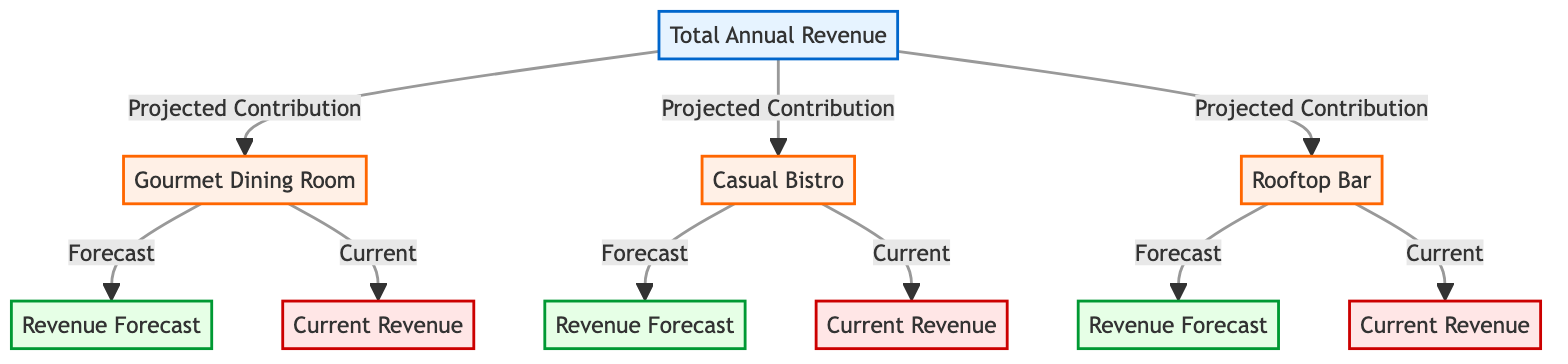What is the total revenue node labeled as? The total revenue node is labeled as "Total Annual Revenue". This can be identified by looking for the node that is the starting point for all projected contributions.
Answer: Total Annual Revenue How many restaurant nodes are present in the diagram? There are three restaurant nodes identified: Gourmet Dining Room, Casual Bistro, and Rooftop Bar. Counting each distinct restaurant node gives a total of three.
Answer: 3 What is the color coding of the current revenue nodes? The current revenue nodes are colored in light red, which corresponds to the class definition specified in the code as "current".
Answer: Light red Which restaurant shows the highest projected contribution? The diagram does not specify exact values, so we cannot determine which restaurant has the highest projected contribution just from the labels. However, each restaurant is represented but not evaluated against one another in terms of projected contributions.
Answer: Cannot determine Which node is connected to the "Total Annual Revenue" node? The "Total Annual Revenue" node connects to three restaurant nodes: Gourmet Dining Room, Casual Bistro, and Rooftop Bar. These connections illustrate the projected contributions from each restaurant.
Answer: Three restaurants What types of revenue insights can be found for each restaurant? Each restaurant node provides insights into both "Revenue Forecast" and "Current Revenue", which are represented as connected nodes for each restaurant. This indicates that there are dual insights for each restaurant.
Answer: Revenue forecast and current revenue How many links are there to the "Gourmet Dining Room" node? The "Gourmet Dining Room" node has two links connected to it: one leading to the "Revenue Forecast" and another to the "Current Revenue". This indicates it has an associated forecast and current revenue.
Answer: 2 What can be inferred about the relationship of the restaurants to the total revenue? Each restaurant is a contributing factor to the "Total Annual Revenue", showing that the revenue generated by each restaurant contributes to the overall revenue figure for the hotel chain.
Answer: Contributing factors What distinctive colors are used for the nodes on the diagram? The distinctive colors used for the nodes are light blue for total revenue, light orange for restaurants, light green for forecasts, and light red for current revenues, which makes the categorization visually clear.
Answer: Light blue, light orange, light green, light red 